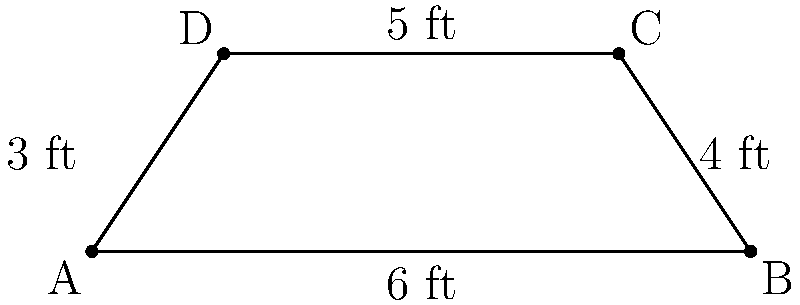In a famous courtroom, the judge's bench is shaped like a trapezoid. The front edge of the bench measures 6 feet, the back edge measures 5 feet, and the depth of the bench is 3 feet. What is the area of the judge's bench in square feet? To find the area of the trapezoidal judge's bench, we'll use the formula for the area of a trapezoid:

$$ A = \frac{1}{2}(b_1 + b_2)h $$

Where:
$A$ = Area
$b_1$ = Length of one parallel side (front edge)
$b_2$ = Length of the other parallel side (back edge)
$h$ = Height (depth of the bench)

Given:
$b_1 = 6$ feet (front edge)
$b_2 = 5$ feet (back edge)
$h = 3$ feet (depth)

Let's substitute these values into the formula:

$$ A = \frac{1}{2}(6 + 5) \times 3 $$

$$ A = \frac{1}{2}(11) \times 3 $$

$$ A = 5.5 \times 3 $$

$$ A = 16.5 $$

Therefore, the area of the judge's bench is 16.5 square feet.
Answer: 16.5 square feet 